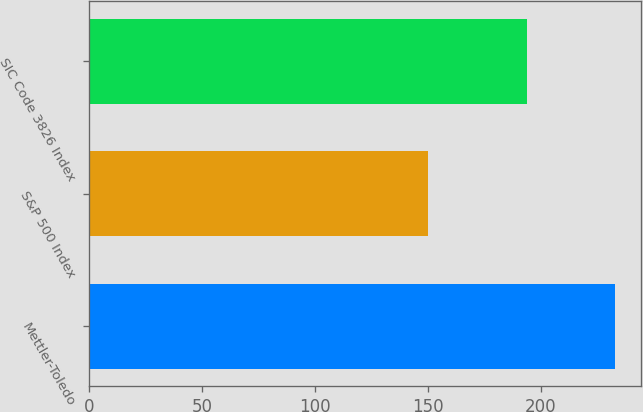Convert chart to OTSL. <chart><loc_0><loc_0><loc_500><loc_500><bar_chart><fcel>Mettler-Toledo<fcel>S&P 500 Index<fcel>SIC Code 3826 Index<nl><fcel>233<fcel>150<fcel>194<nl></chart> 